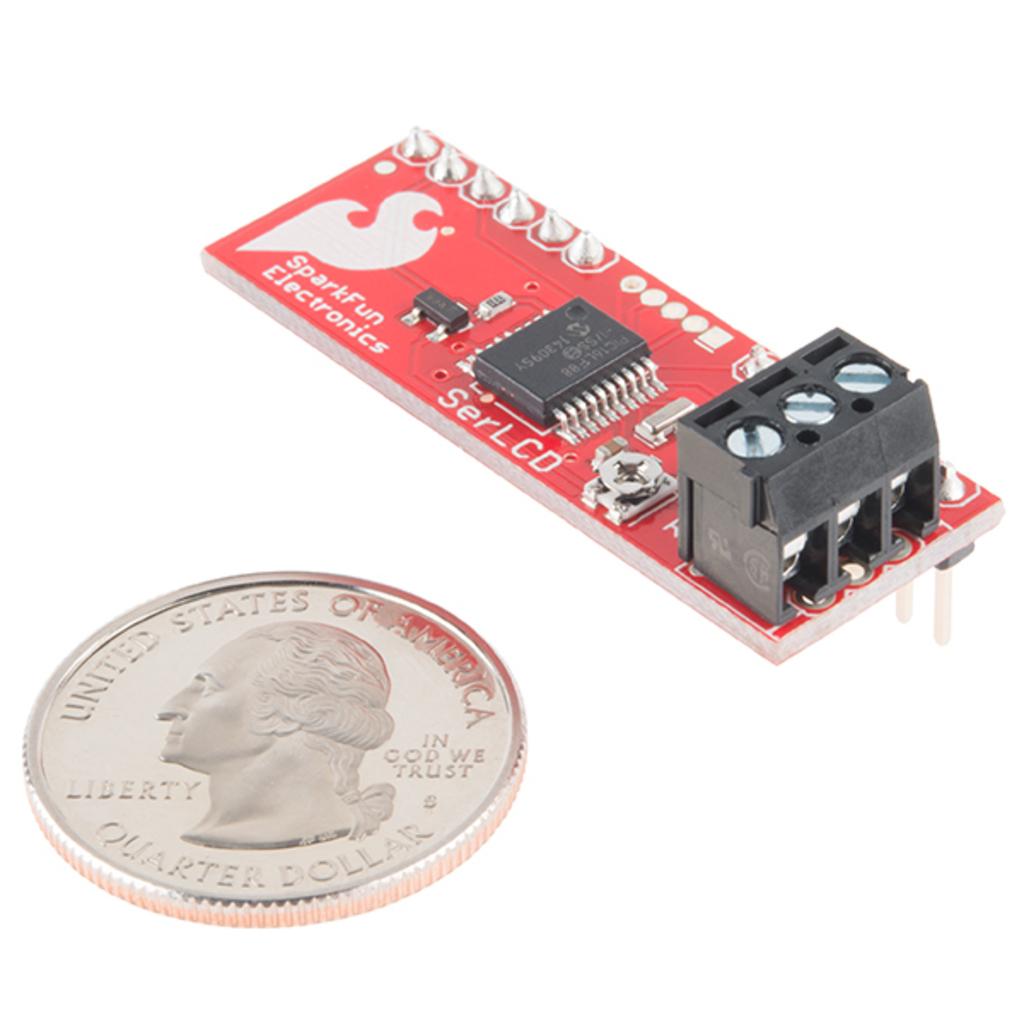Does sparkfun make microchips?
Make the answer very short. Yes. 